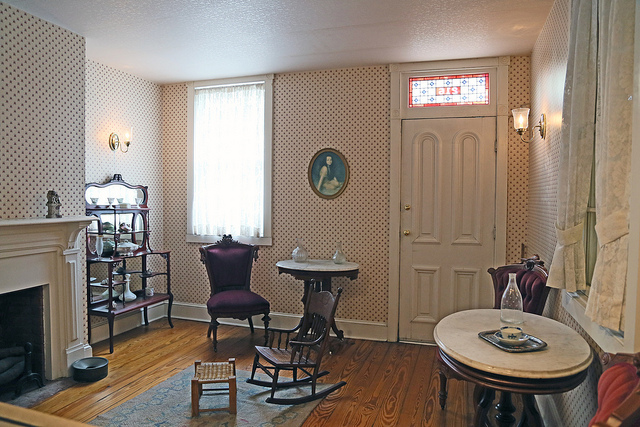Please transcribe the text in this image. 916 